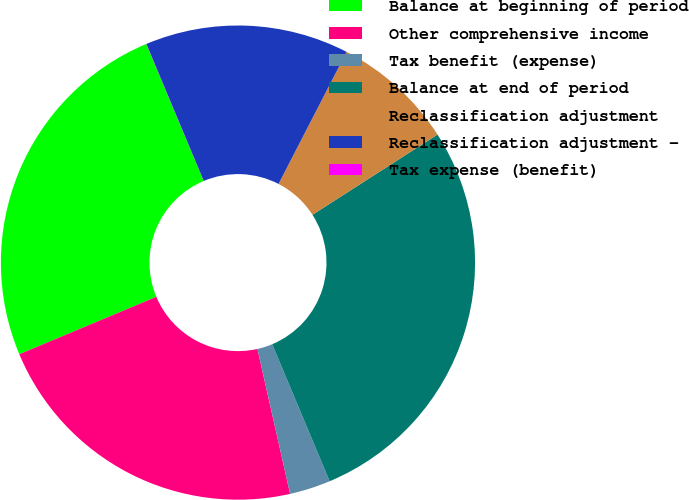<chart> <loc_0><loc_0><loc_500><loc_500><pie_chart><fcel>Balance at beginning of period<fcel>Other comprehensive income<fcel>Tax benefit (expense)<fcel>Balance at end of period<fcel>Reclassification adjustment<fcel>Reclassification adjustment -<fcel>Tax expense (benefit)<nl><fcel>24.99%<fcel>22.21%<fcel>2.79%<fcel>27.76%<fcel>8.34%<fcel>13.89%<fcel>0.01%<nl></chart> 